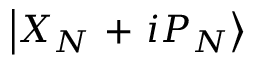<formula> <loc_0><loc_0><loc_500><loc_500>\left | { { X } _ { N } } + i { { P } _ { N } } \right \rangle</formula> 